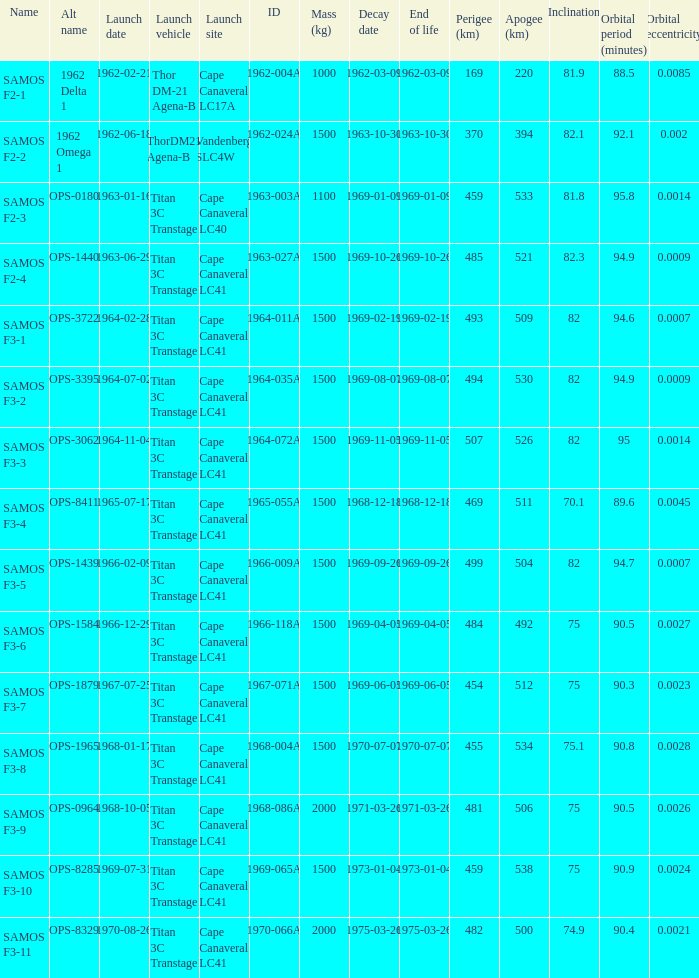What was the peak perigee reached on the 9th of january, 1969? 459.0. 